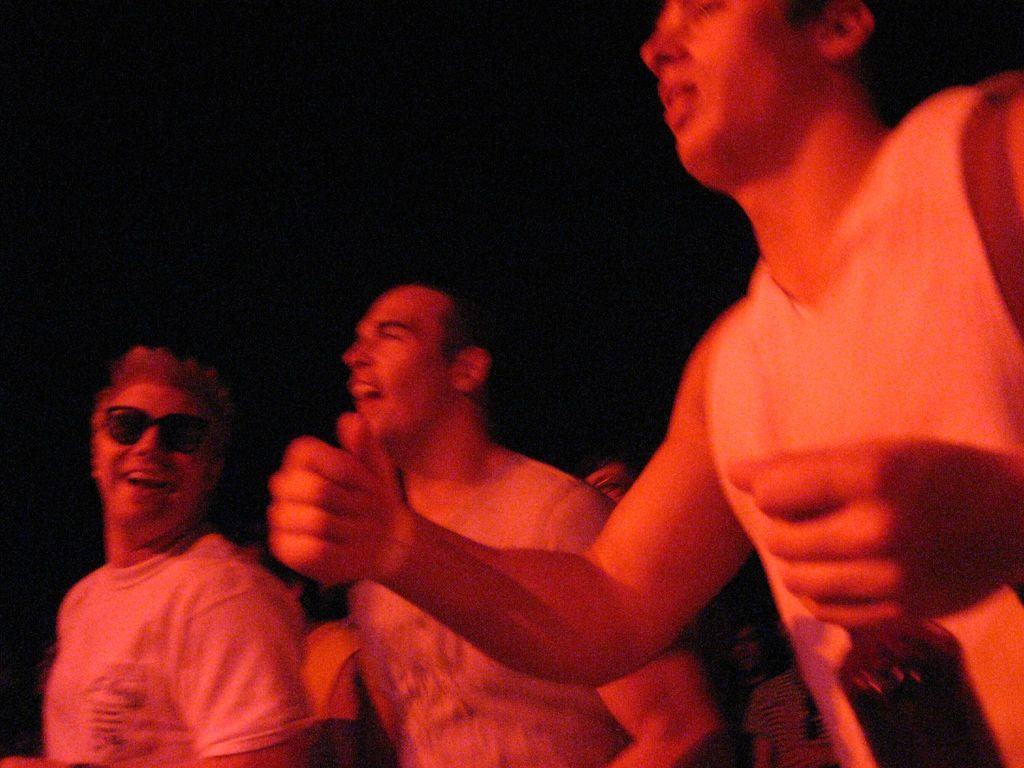How many men are in the image? There are three men in the image. What is one of the men holding in his hand? One man is holding a bottle in his hand. Can you describe the background of the image? There are people in the background of the image. What type of cheese is being served on the airplane in the image? There is no airplane or cheese present in the image; it features three men and a background with people. 